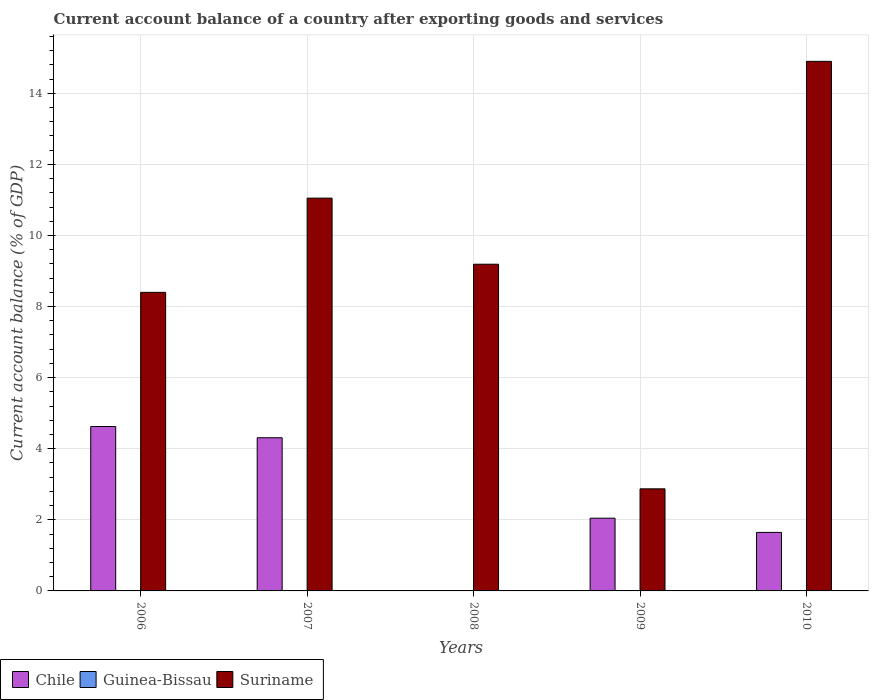Are the number of bars per tick equal to the number of legend labels?
Offer a very short reply. No. Are the number of bars on each tick of the X-axis equal?
Your response must be concise. No. How many bars are there on the 4th tick from the left?
Offer a terse response. 2. What is the label of the 1st group of bars from the left?
Offer a very short reply. 2006. What is the account balance in Suriname in 2009?
Offer a very short reply. 2.87. Across all years, what is the maximum account balance in Chile?
Give a very brief answer. 4.63. What is the difference between the account balance in Suriname in 2007 and that in 2008?
Provide a succinct answer. 1.86. What is the difference between the account balance in Guinea-Bissau in 2009 and the account balance in Chile in 2006?
Your response must be concise. -4.63. What is the average account balance in Suriname per year?
Ensure brevity in your answer.  9.28. What is the ratio of the account balance in Suriname in 2008 to that in 2010?
Your answer should be very brief. 0.62. Is the account balance in Suriname in 2006 less than that in 2009?
Your response must be concise. No. What is the difference between the highest and the second highest account balance in Chile?
Provide a short and direct response. 0.32. What is the difference between the highest and the lowest account balance in Chile?
Provide a short and direct response. 4.63. In how many years, is the account balance in Chile greater than the average account balance in Chile taken over all years?
Provide a short and direct response. 2. Is the sum of the account balance in Suriname in 2006 and 2008 greater than the maximum account balance in Chile across all years?
Offer a very short reply. Yes. Is it the case that in every year, the sum of the account balance in Suriname and account balance in Guinea-Bissau is greater than the account balance in Chile?
Your response must be concise. Yes. How many bars are there?
Keep it short and to the point. 9. Are all the bars in the graph horizontal?
Your answer should be very brief. No. Are the values on the major ticks of Y-axis written in scientific E-notation?
Make the answer very short. No. Does the graph contain grids?
Give a very brief answer. Yes. Where does the legend appear in the graph?
Give a very brief answer. Bottom left. What is the title of the graph?
Your answer should be compact. Current account balance of a country after exporting goods and services. Does "Angola" appear as one of the legend labels in the graph?
Ensure brevity in your answer.  No. What is the label or title of the X-axis?
Make the answer very short. Years. What is the label or title of the Y-axis?
Keep it short and to the point. Current account balance (% of GDP). What is the Current account balance (% of GDP) of Chile in 2006?
Provide a short and direct response. 4.63. What is the Current account balance (% of GDP) in Suriname in 2006?
Keep it short and to the point. 8.4. What is the Current account balance (% of GDP) in Chile in 2007?
Provide a short and direct response. 4.31. What is the Current account balance (% of GDP) of Suriname in 2007?
Provide a short and direct response. 11.05. What is the Current account balance (% of GDP) of Chile in 2008?
Your response must be concise. 0. What is the Current account balance (% of GDP) of Suriname in 2008?
Ensure brevity in your answer.  9.19. What is the Current account balance (% of GDP) in Chile in 2009?
Your response must be concise. 2.05. What is the Current account balance (% of GDP) of Suriname in 2009?
Offer a terse response. 2.87. What is the Current account balance (% of GDP) of Chile in 2010?
Your answer should be compact. 1.65. What is the Current account balance (% of GDP) in Guinea-Bissau in 2010?
Give a very brief answer. 0. What is the Current account balance (% of GDP) in Suriname in 2010?
Your answer should be very brief. 14.9. Across all years, what is the maximum Current account balance (% of GDP) in Chile?
Your answer should be very brief. 4.63. Across all years, what is the maximum Current account balance (% of GDP) of Suriname?
Give a very brief answer. 14.9. Across all years, what is the minimum Current account balance (% of GDP) of Suriname?
Ensure brevity in your answer.  2.87. What is the total Current account balance (% of GDP) in Chile in the graph?
Offer a very short reply. 12.63. What is the total Current account balance (% of GDP) of Suriname in the graph?
Provide a short and direct response. 46.41. What is the difference between the Current account balance (% of GDP) in Chile in 2006 and that in 2007?
Provide a succinct answer. 0.32. What is the difference between the Current account balance (% of GDP) in Suriname in 2006 and that in 2007?
Provide a short and direct response. -2.65. What is the difference between the Current account balance (% of GDP) of Suriname in 2006 and that in 2008?
Provide a succinct answer. -0.79. What is the difference between the Current account balance (% of GDP) in Chile in 2006 and that in 2009?
Your answer should be compact. 2.58. What is the difference between the Current account balance (% of GDP) of Suriname in 2006 and that in 2009?
Give a very brief answer. 5.53. What is the difference between the Current account balance (% of GDP) of Chile in 2006 and that in 2010?
Your answer should be compact. 2.98. What is the difference between the Current account balance (% of GDP) in Suriname in 2006 and that in 2010?
Give a very brief answer. -6.5. What is the difference between the Current account balance (% of GDP) in Suriname in 2007 and that in 2008?
Keep it short and to the point. 1.86. What is the difference between the Current account balance (% of GDP) of Chile in 2007 and that in 2009?
Your answer should be very brief. 2.26. What is the difference between the Current account balance (% of GDP) of Suriname in 2007 and that in 2009?
Your response must be concise. 8.18. What is the difference between the Current account balance (% of GDP) in Chile in 2007 and that in 2010?
Your answer should be compact. 2.66. What is the difference between the Current account balance (% of GDP) of Suriname in 2007 and that in 2010?
Your answer should be compact. -3.85. What is the difference between the Current account balance (% of GDP) in Suriname in 2008 and that in 2009?
Provide a short and direct response. 6.32. What is the difference between the Current account balance (% of GDP) in Suriname in 2008 and that in 2010?
Offer a very short reply. -5.71. What is the difference between the Current account balance (% of GDP) of Chile in 2009 and that in 2010?
Provide a succinct answer. 0.4. What is the difference between the Current account balance (% of GDP) in Suriname in 2009 and that in 2010?
Offer a very short reply. -12.03. What is the difference between the Current account balance (% of GDP) in Chile in 2006 and the Current account balance (% of GDP) in Suriname in 2007?
Offer a terse response. -6.42. What is the difference between the Current account balance (% of GDP) in Chile in 2006 and the Current account balance (% of GDP) in Suriname in 2008?
Your answer should be very brief. -4.57. What is the difference between the Current account balance (% of GDP) of Chile in 2006 and the Current account balance (% of GDP) of Suriname in 2009?
Provide a succinct answer. 1.75. What is the difference between the Current account balance (% of GDP) in Chile in 2006 and the Current account balance (% of GDP) in Suriname in 2010?
Offer a terse response. -10.27. What is the difference between the Current account balance (% of GDP) in Chile in 2007 and the Current account balance (% of GDP) in Suriname in 2008?
Offer a terse response. -4.88. What is the difference between the Current account balance (% of GDP) in Chile in 2007 and the Current account balance (% of GDP) in Suriname in 2009?
Provide a succinct answer. 1.44. What is the difference between the Current account balance (% of GDP) of Chile in 2007 and the Current account balance (% of GDP) of Suriname in 2010?
Ensure brevity in your answer.  -10.59. What is the difference between the Current account balance (% of GDP) in Chile in 2009 and the Current account balance (% of GDP) in Suriname in 2010?
Your response must be concise. -12.85. What is the average Current account balance (% of GDP) of Chile per year?
Give a very brief answer. 2.53. What is the average Current account balance (% of GDP) of Guinea-Bissau per year?
Ensure brevity in your answer.  0. What is the average Current account balance (% of GDP) of Suriname per year?
Make the answer very short. 9.28. In the year 2006, what is the difference between the Current account balance (% of GDP) of Chile and Current account balance (% of GDP) of Suriname?
Give a very brief answer. -3.77. In the year 2007, what is the difference between the Current account balance (% of GDP) of Chile and Current account balance (% of GDP) of Suriname?
Offer a terse response. -6.74. In the year 2009, what is the difference between the Current account balance (% of GDP) in Chile and Current account balance (% of GDP) in Suriname?
Offer a terse response. -0.83. In the year 2010, what is the difference between the Current account balance (% of GDP) of Chile and Current account balance (% of GDP) of Suriname?
Your answer should be very brief. -13.25. What is the ratio of the Current account balance (% of GDP) in Chile in 2006 to that in 2007?
Ensure brevity in your answer.  1.07. What is the ratio of the Current account balance (% of GDP) in Suriname in 2006 to that in 2007?
Your answer should be very brief. 0.76. What is the ratio of the Current account balance (% of GDP) in Suriname in 2006 to that in 2008?
Offer a terse response. 0.91. What is the ratio of the Current account balance (% of GDP) of Chile in 2006 to that in 2009?
Provide a succinct answer. 2.26. What is the ratio of the Current account balance (% of GDP) of Suriname in 2006 to that in 2009?
Make the answer very short. 2.92. What is the ratio of the Current account balance (% of GDP) in Chile in 2006 to that in 2010?
Offer a very short reply. 2.81. What is the ratio of the Current account balance (% of GDP) in Suriname in 2006 to that in 2010?
Make the answer very short. 0.56. What is the ratio of the Current account balance (% of GDP) in Suriname in 2007 to that in 2008?
Keep it short and to the point. 1.2. What is the ratio of the Current account balance (% of GDP) of Chile in 2007 to that in 2009?
Make the answer very short. 2.11. What is the ratio of the Current account balance (% of GDP) of Suriname in 2007 to that in 2009?
Your answer should be very brief. 3.85. What is the ratio of the Current account balance (% of GDP) in Chile in 2007 to that in 2010?
Your answer should be compact. 2.62. What is the ratio of the Current account balance (% of GDP) in Suriname in 2007 to that in 2010?
Give a very brief answer. 0.74. What is the ratio of the Current account balance (% of GDP) of Suriname in 2008 to that in 2009?
Your answer should be compact. 3.2. What is the ratio of the Current account balance (% of GDP) in Suriname in 2008 to that in 2010?
Provide a short and direct response. 0.62. What is the ratio of the Current account balance (% of GDP) in Chile in 2009 to that in 2010?
Provide a short and direct response. 1.24. What is the ratio of the Current account balance (% of GDP) of Suriname in 2009 to that in 2010?
Give a very brief answer. 0.19. What is the difference between the highest and the second highest Current account balance (% of GDP) of Chile?
Offer a terse response. 0.32. What is the difference between the highest and the second highest Current account balance (% of GDP) in Suriname?
Your answer should be compact. 3.85. What is the difference between the highest and the lowest Current account balance (% of GDP) of Chile?
Ensure brevity in your answer.  4.63. What is the difference between the highest and the lowest Current account balance (% of GDP) in Suriname?
Keep it short and to the point. 12.03. 